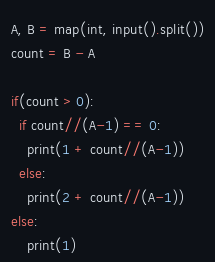Convert code to text. <code><loc_0><loc_0><loc_500><loc_500><_Python_>A, B = map(int, input().split())
count = B - A

if(count > 0):
  if count//(A-1) == 0:
	print(1 + count//(A-1))
  else:
    print(2 + count//(A-1))
else:
	print(1)
</code> 